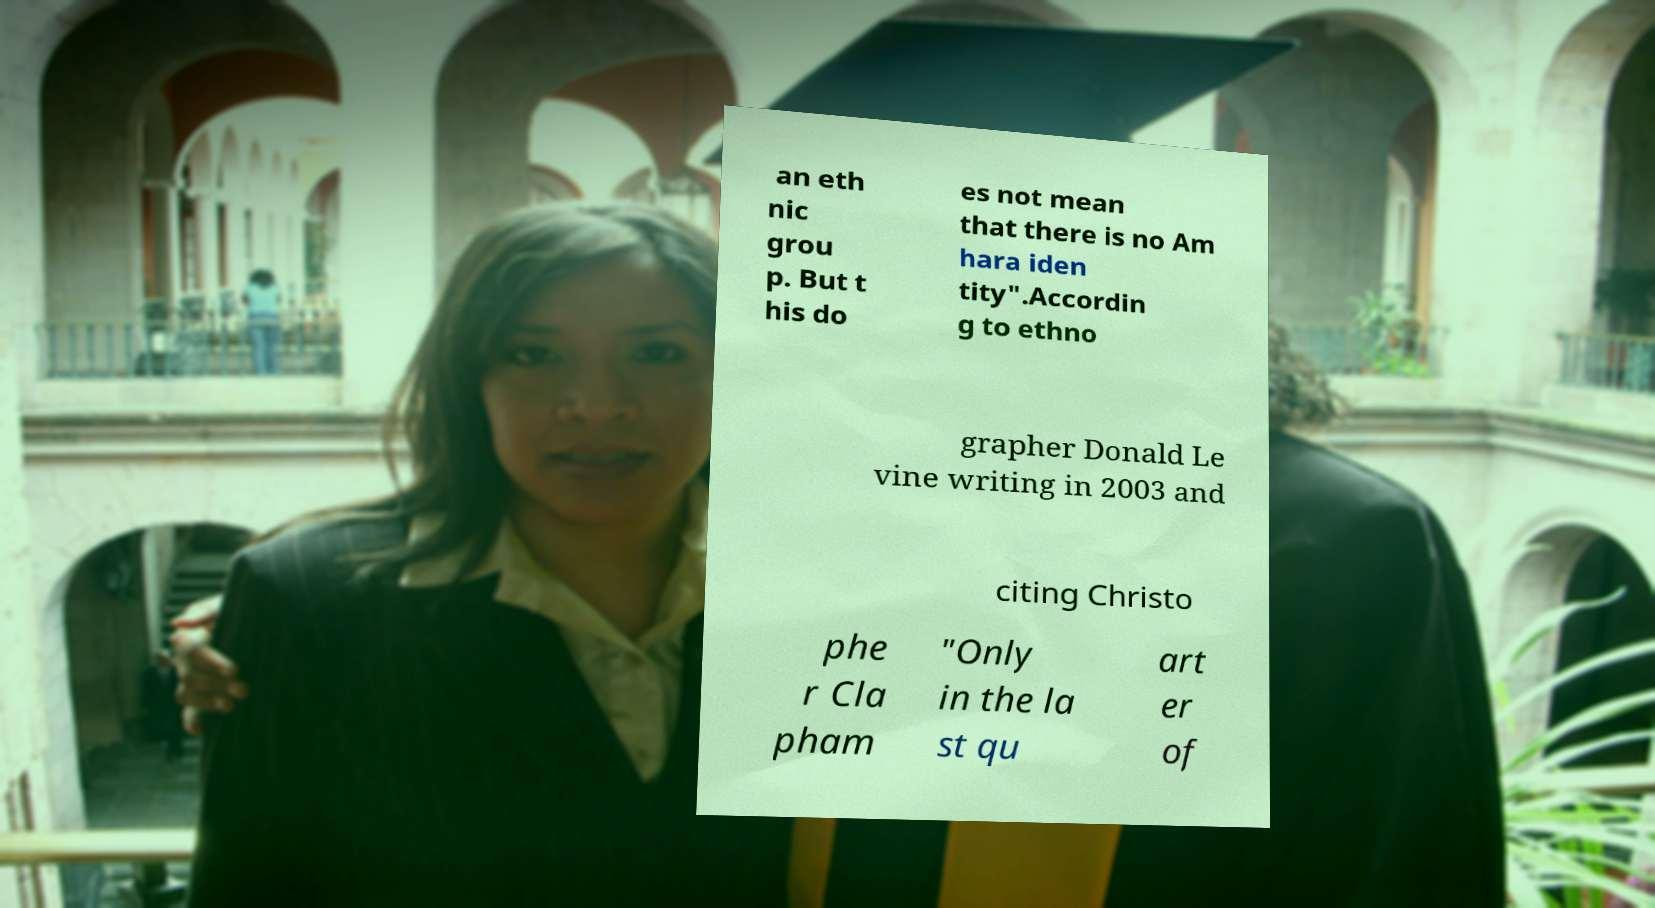Could you assist in decoding the text presented in this image and type it out clearly? an eth nic grou p. But t his do es not mean that there is no Am hara iden tity".Accordin g to ethno grapher Donald Le vine writing in 2003 and citing Christo phe r Cla pham "Only in the la st qu art er of 